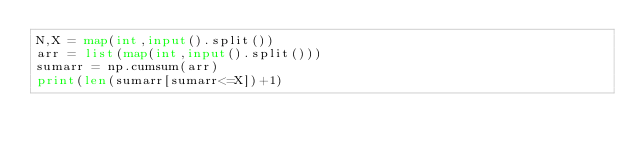Convert code to text. <code><loc_0><loc_0><loc_500><loc_500><_Python_>N,X = map(int,input().split())
arr = list(map(int,input().split()))
sumarr = np.cumsum(arr)
print(len(sumarr[sumarr<=X])+1)
</code> 